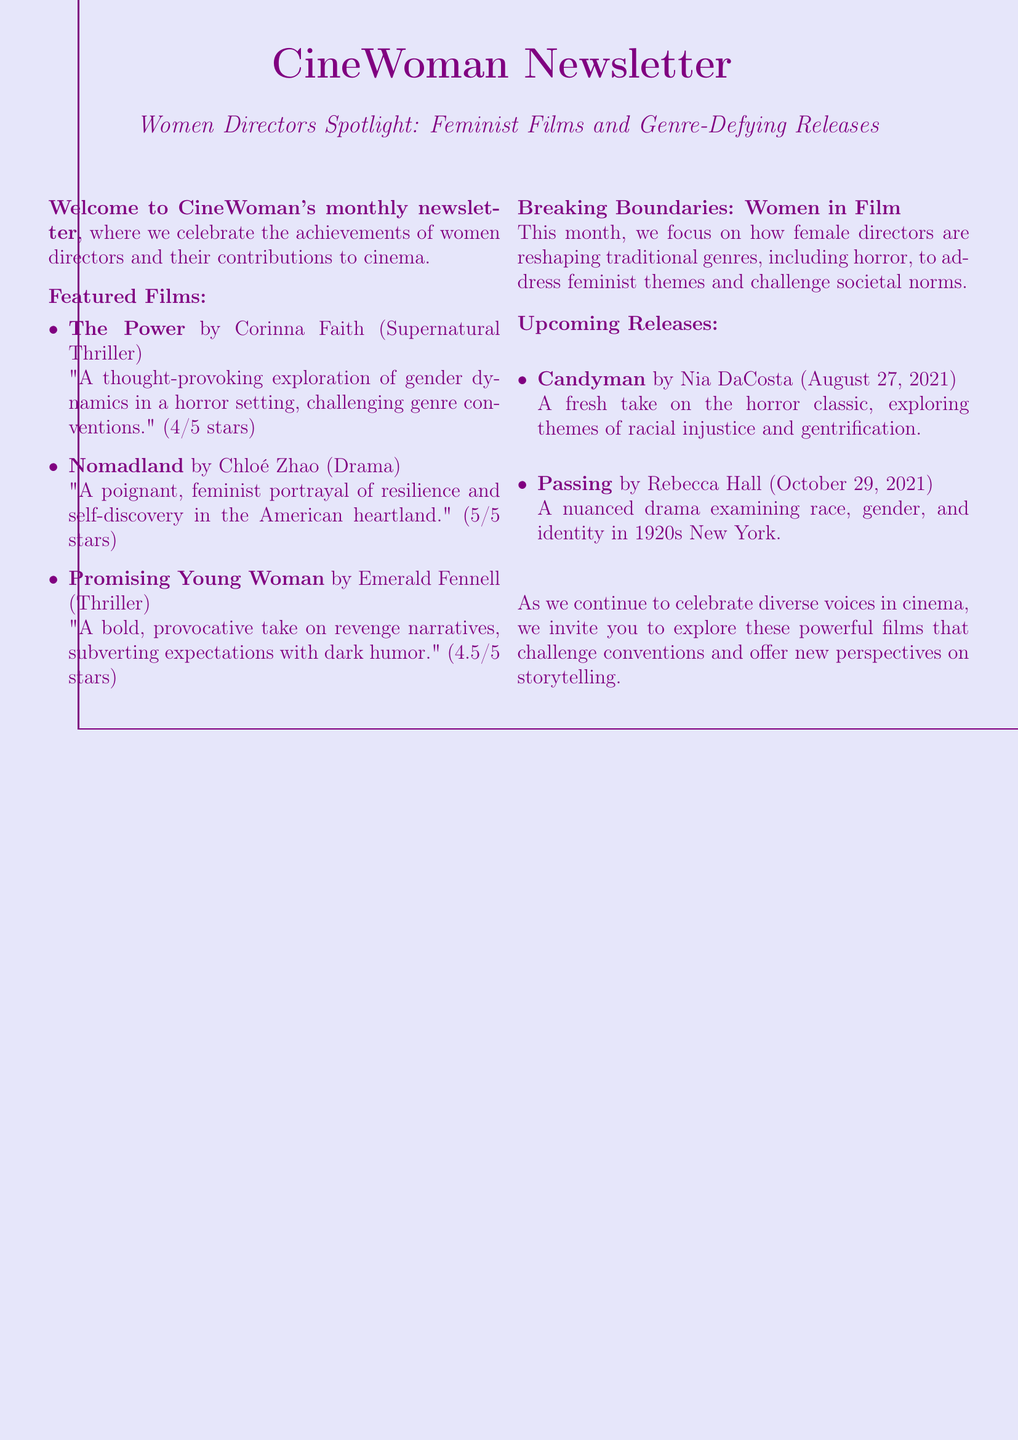What is the title of the newsletter? The title of the newsletter is given at the top of the document, referring to the specific edition that focuses on women directors.
Answer: CineWoman Newsletter Who directed "Nomadland"? The document lists the director of "Nomadland" in the featured films section.
Answer: Chloé Zhao What genre does "The Power" belong to? The genre of "The Power" is specified next to its title in the featured films list.
Answer: Supernatural Thriller How many stars did "Promising Young Woman" receive? The rating for "Promising Young Woman" is clearly stated in the review snippet provided in the document.
Answer: 4.5/5 stars What is the release date for "Passing"? The document provides the release date for "Passing" in the upcoming releases section.
Answer: October 29, 2021 What is the main theme discussed in the "Breaking Boundaries: Women in Film" section? This section focuses on how female directors address a specific topic through traditional genres, which can be inferred from the summary.
Answer: Feminist themes What is the content of the "spotlight section"? The spotlight section includes a brief description of the focus of this month's newsletter, emphasizing the contributions of women directors.
Answer: Female directors reshaping traditional genres Which film examines racial injustice and gentrification? The description of upcoming releases explicitly mentions a film that explores these themes.
Answer: Candyman 